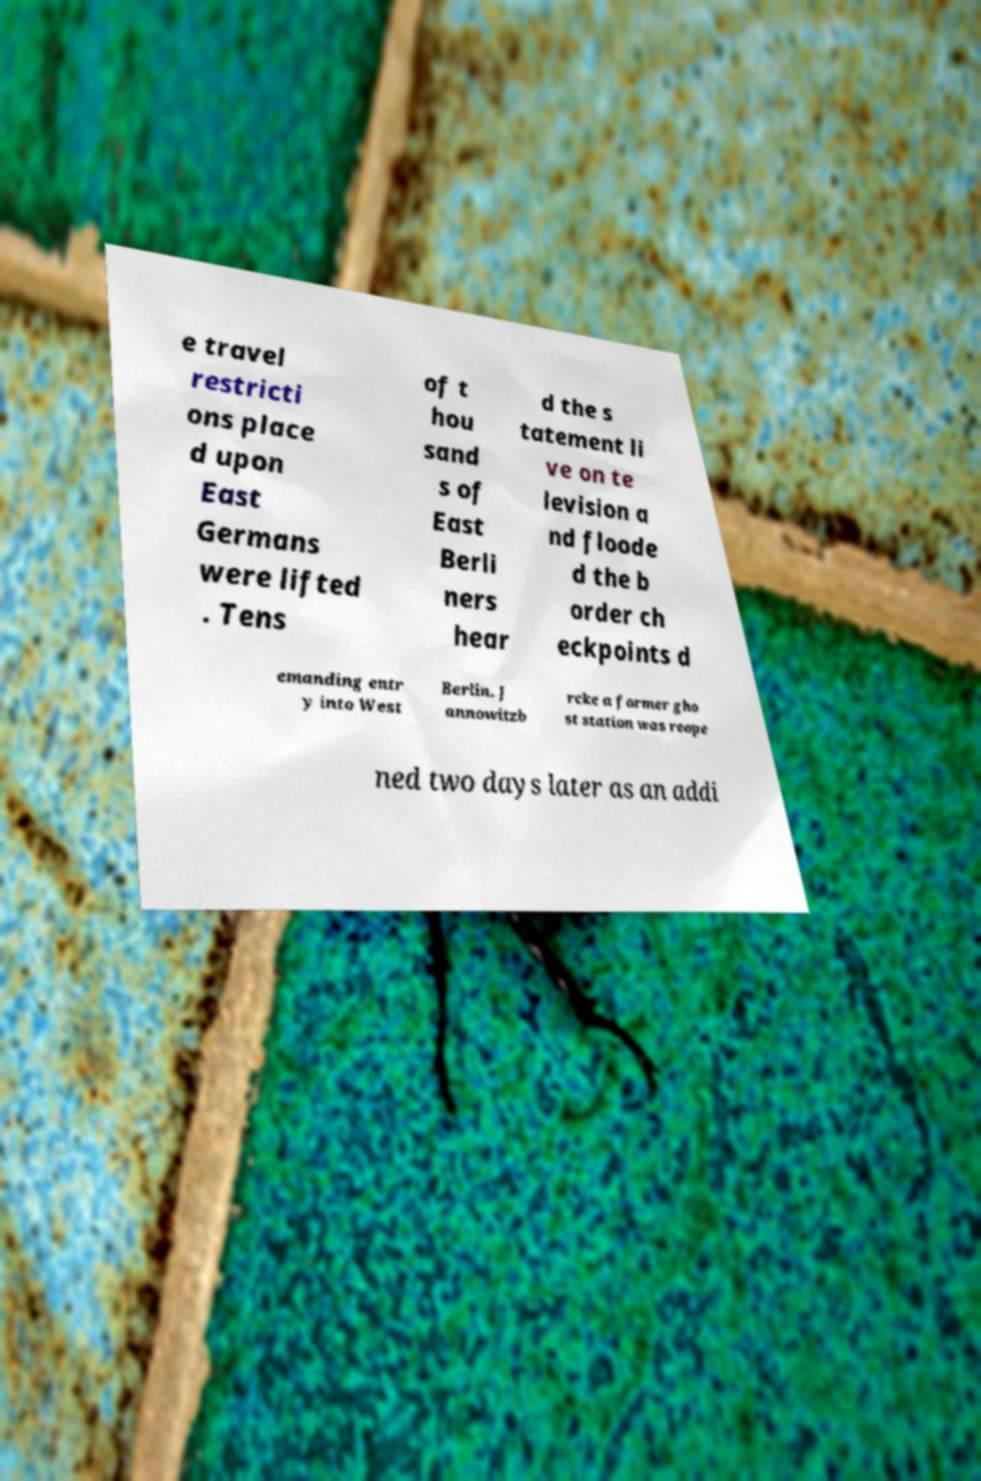Can you read and provide the text displayed in the image?This photo seems to have some interesting text. Can you extract and type it out for me? e travel restricti ons place d upon East Germans were lifted . Tens of t hou sand s of East Berli ners hear d the s tatement li ve on te levision a nd floode d the b order ch eckpoints d emanding entr y into West Berlin. J annowitzb rcke a former gho st station was reope ned two days later as an addi 